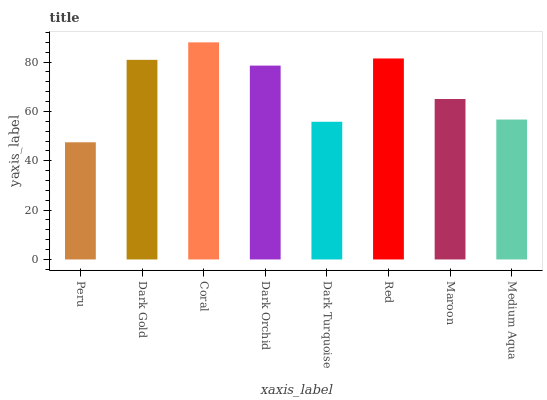Is Peru the minimum?
Answer yes or no. Yes. Is Coral the maximum?
Answer yes or no. Yes. Is Dark Gold the minimum?
Answer yes or no. No. Is Dark Gold the maximum?
Answer yes or no. No. Is Dark Gold greater than Peru?
Answer yes or no. Yes. Is Peru less than Dark Gold?
Answer yes or no. Yes. Is Peru greater than Dark Gold?
Answer yes or no. No. Is Dark Gold less than Peru?
Answer yes or no. No. Is Dark Orchid the high median?
Answer yes or no. Yes. Is Maroon the low median?
Answer yes or no. Yes. Is Coral the high median?
Answer yes or no. No. Is Peru the low median?
Answer yes or no. No. 